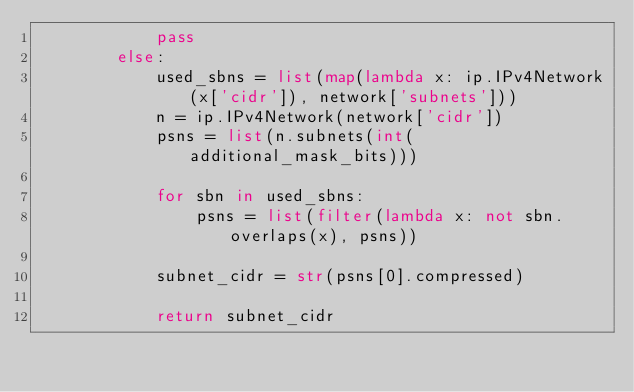Convert code to text. <code><loc_0><loc_0><loc_500><loc_500><_Python_>            pass
        else:
            used_sbns = list(map(lambda x: ip.IPv4Network(x['cidr']), network['subnets']))
            n = ip.IPv4Network(network['cidr'])
            psns = list(n.subnets(int(additional_mask_bits)))

            for sbn in used_sbns:
                psns = list(filter(lambda x: not sbn.overlaps(x), psns))

            subnet_cidr = str(psns[0].compressed)

            return subnet_cidr
</code> 